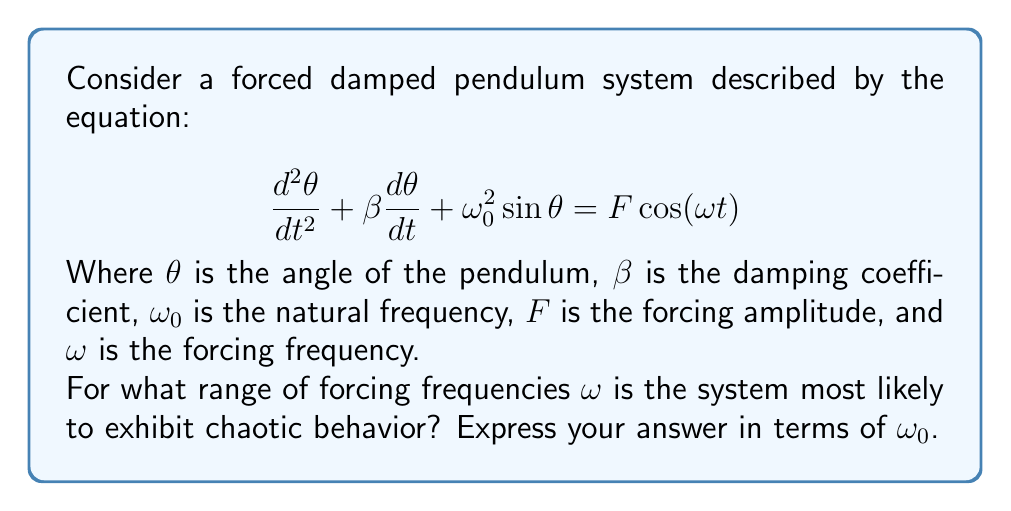Provide a solution to this math problem. To determine the range of forcing frequencies where chaotic behavior is most likely to occur, we need to consider the following steps:

1. Understand the natural frequency:
   The natural frequency $\omega_0$ represents the oscillation frequency of the undamped, unforced pendulum.

2. Consider the resonance condition:
   Resonance occurs when the forcing frequency matches the natural frequency, i.e., $\omega \approx \omega_0$.

3. Analyze the subharmonic resonances:
   Chaotic behavior often emerges near subharmonic resonances, which occur at fractions of the natural frequency.

4. Examine the period-doubling route to chaos:
   As the forcing frequency decreases, the system may undergo period-doubling bifurcations, leading to chaos.

5. Determine the frequency range:
   Chaos is most likely to occur in a range slightly below the natural frequency, typically between $\frac{2}{3}\omega_0$ and $\omega_0$.

This range encompasses:
- The main resonance ($\omega \approx \omega_0$)
- Important subharmonic resonances (e.g., $\omega \approx \frac{2}{3}\omega_0$, $\omega \approx \frac{3}{4}\omega_0$)
- The frequency region where period-doubling cascades are often observed

The exact range may vary depending on other system parameters (e.g., damping coefficient, forcing amplitude), but this general range is a good approximation for many forced damped pendulum systems.
Answer: $\frac{2}{3}\omega_0 < \omega < \omega_0$ 